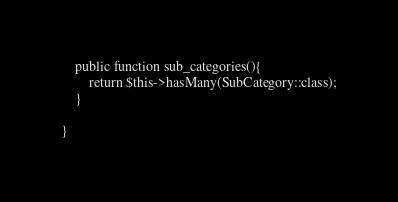Convert code to text. <code><loc_0><loc_0><loc_500><loc_500><_PHP_>    public function sub_categories(){
        return $this->hasMany(SubCategory::class);
    }

}
</code> 